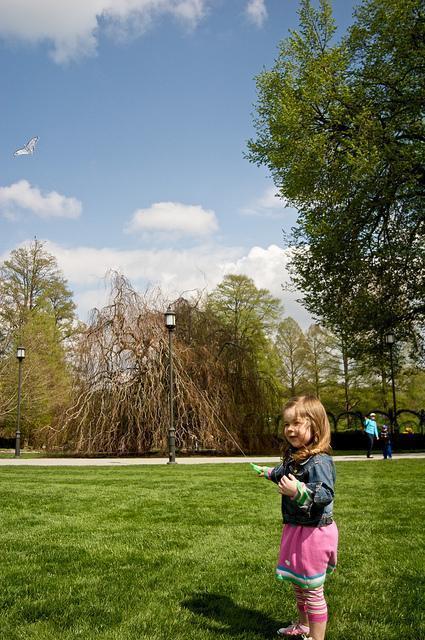How many people are in the photo?
Give a very brief answer. 3. How many people are there?
Give a very brief answer. 3. 